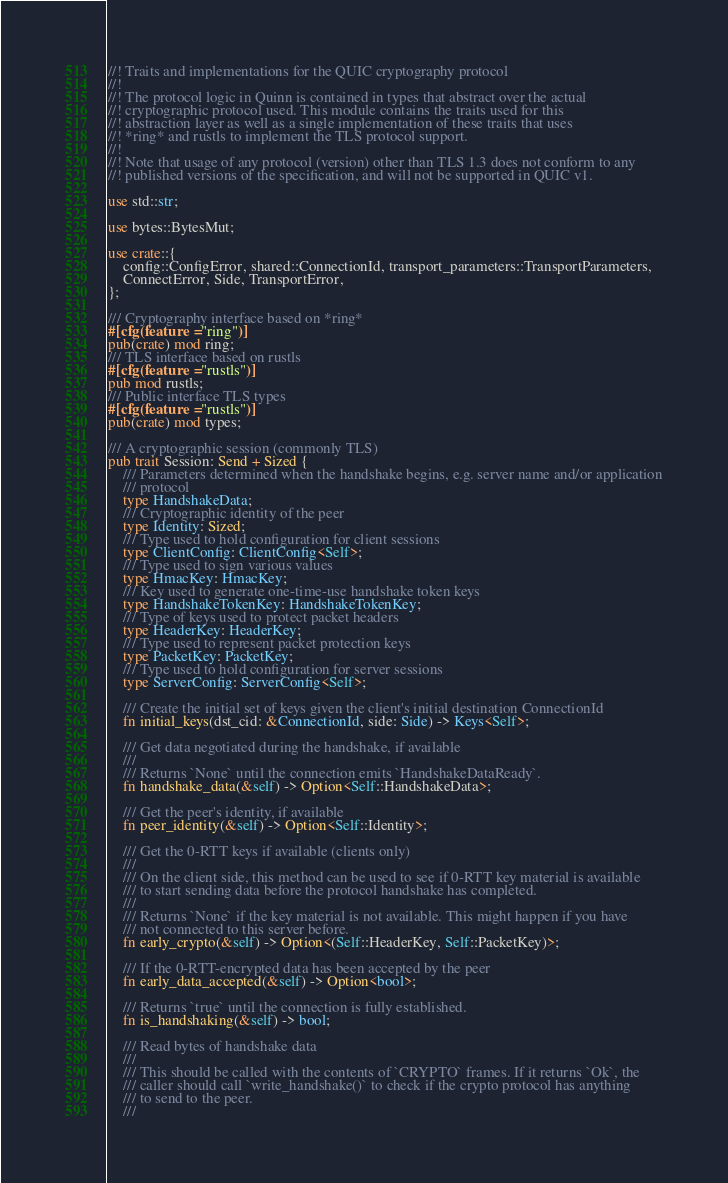Convert code to text. <code><loc_0><loc_0><loc_500><loc_500><_Rust_>//! Traits and implementations for the QUIC cryptography protocol
//!
//! The protocol logic in Quinn is contained in types that abstract over the actual
//! cryptographic protocol used. This module contains the traits used for this
//! abstraction layer as well as a single implementation of these traits that uses
//! *ring* and rustls to implement the TLS protocol support.
//!
//! Note that usage of any protocol (version) other than TLS 1.3 does not conform to any
//! published versions of the specification, and will not be supported in QUIC v1.

use std::str;

use bytes::BytesMut;

use crate::{
    config::ConfigError, shared::ConnectionId, transport_parameters::TransportParameters,
    ConnectError, Side, TransportError,
};

/// Cryptography interface based on *ring*
#[cfg(feature = "ring")]
pub(crate) mod ring;
/// TLS interface based on rustls
#[cfg(feature = "rustls")]
pub mod rustls;
/// Public interface TLS types
#[cfg(feature = "rustls")]
pub(crate) mod types;

/// A cryptographic session (commonly TLS)
pub trait Session: Send + Sized {
    /// Parameters determined when the handshake begins, e.g. server name and/or application
    /// protocol
    type HandshakeData;
    /// Cryptographic identity of the peer
    type Identity: Sized;
    /// Type used to hold configuration for client sessions
    type ClientConfig: ClientConfig<Self>;
    /// Type used to sign various values
    type HmacKey: HmacKey;
    /// Key used to generate one-time-use handshake token keys
    type HandshakeTokenKey: HandshakeTokenKey;
    /// Type of keys used to protect packet headers
    type HeaderKey: HeaderKey;
    /// Type used to represent packet protection keys
    type PacketKey: PacketKey;
    /// Type used to hold configuration for server sessions
    type ServerConfig: ServerConfig<Self>;

    /// Create the initial set of keys given the client's initial destination ConnectionId
    fn initial_keys(dst_cid: &ConnectionId, side: Side) -> Keys<Self>;

    /// Get data negotiated during the handshake, if available
    ///
    /// Returns `None` until the connection emits `HandshakeDataReady`.
    fn handshake_data(&self) -> Option<Self::HandshakeData>;

    /// Get the peer's identity, if available
    fn peer_identity(&self) -> Option<Self::Identity>;

    /// Get the 0-RTT keys if available (clients only)
    ///
    /// On the client side, this method can be used to see if 0-RTT key material is available
    /// to start sending data before the protocol handshake has completed.
    ///
    /// Returns `None` if the key material is not available. This might happen if you have
    /// not connected to this server before.
    fn early_crypto(&self) -> Option<(Self::HeaderKey, Self::PacketKey)>;

    /// If the 0-RTT-encrypted data has been accepted by the peer
    fn early_data_accepted(&self) -> Option<bool>;

    /// Returns `true` until the connection is fully established.
    fn is_handshaking(&self) -> bool;

    /// Read bytes of handshake data
    ///
    /// This should be called with the contents of `CRYPTO` frames. If it returns `Ok`, the
    /// caller should call `write_handshake()` to check if the crypto protocol has anything
    /// to send to the peer.
    ///</code> 